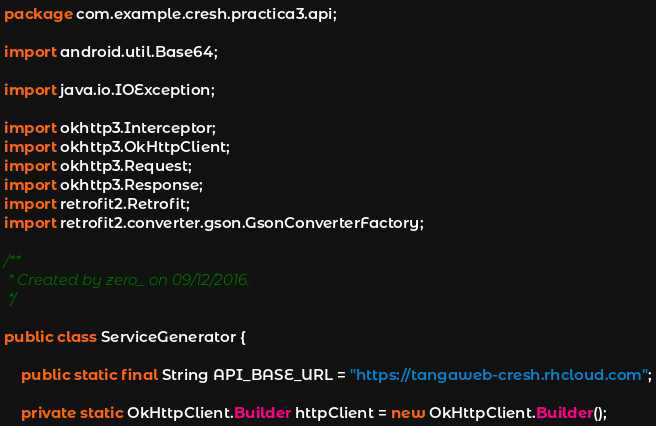Convert code to text. <code><loc_0><loc_0><loc_500><loc_500><_Java_>package com.example.cresh.practica3.api;

import android.util.Base64;

import java.io.IOException;

import okhttp3.Interceptor;
import okhttp3.OkHttpClient;
import okhttp3.Request;
import okhttp3.Response;
import retrofit2.Retrofit;
import retrofit2.converter.gson.GsonConverterFactory;

/**
 * Created by zero_ on 09/12/2016.
 */

public class ServiceGenerator {

    public static final String API_BASE_URL = "https://tangaweb-cresh.rhcloud.com";

    private static OkHttpClient.Builder httpClient = new OkHttpClient.Builder();
</code> 